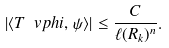Convert formula to latex. <formula><loc_0><loc_0><loc_500><loc_500>| \langle T \ v p h i , \, \psi \rangle | \leq \frac { C } { \ell ( R _ { k } ) ^ { n } } .</formula> 